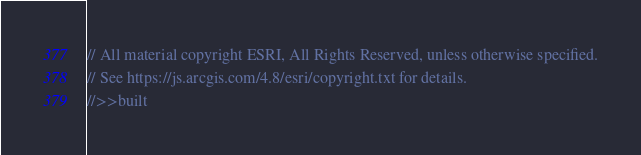<code> <loc_0><loc_0><loc_500><loc_500><_JavaScript_>// All material copyright ESRI, All Rights Reserved, unless otherwise specified.
// See https://js.arcgis.com/4.8/esri/copyright.txt for details.
//>>built</code> 